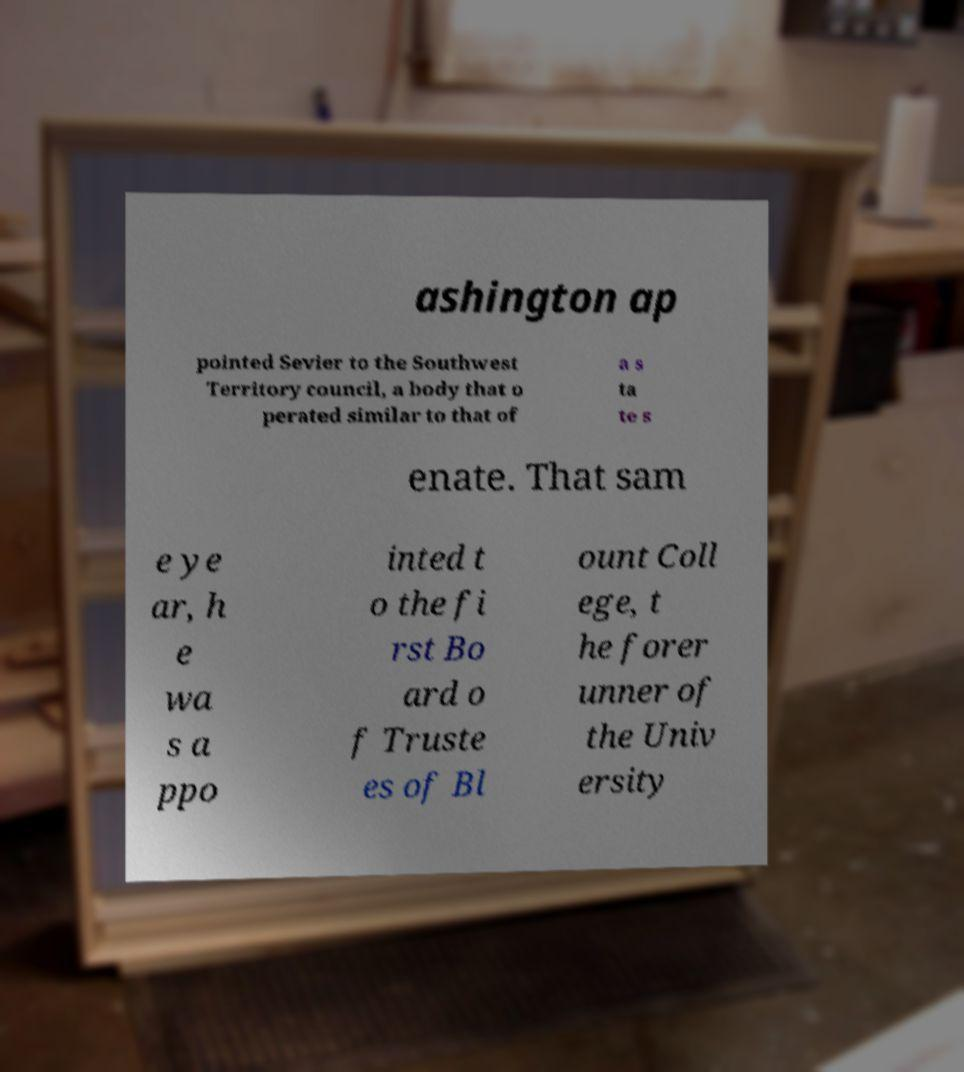I need the written content from this picture converted into text. Can you do that? ashington ap pointed Sevier to the Southwest Territory council, a body that o perated similar to that of a s ta te s enate. That sam e ye ar, h e wa s a ppo inted t o the fi rst Bo ard o f Truste es of Bl ount Coll ege, t he forer unner of the Univ ersity 